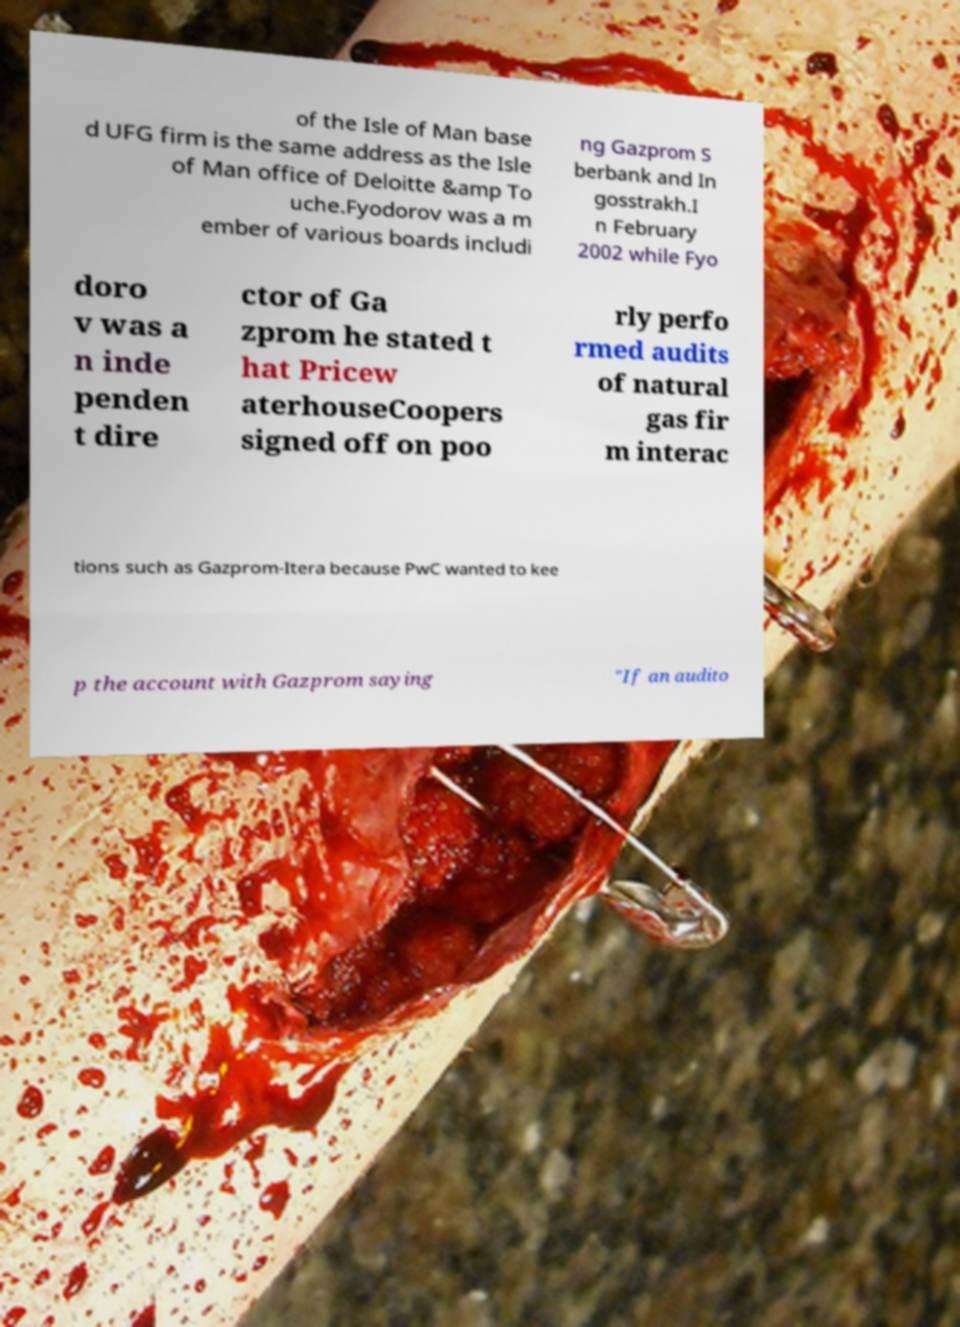What messages or text are displayed in this image? I need them in a readable, typed format. of the Isle of Man base d UFG firm is the same address as the Isle of Man office of Deloitte &amp To uche.Fyodorov was a m ember of various boards includi ng Gazprom S berbank and In gosstrakh.I n February 2002 while Fyo doro v was a n inde penden t dire ctor of Ga zprom he stated t hat Pricew aterhouseCoopers signed off on poo rly perfo rmed audits of natural gas fir m interac tions such as Gazprom-Itera because PwC wanted to kee p the account with Gazprom saying "If an audito 